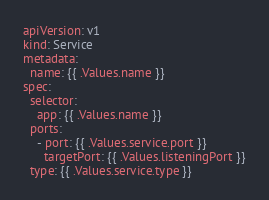Convert code to text. <code><loc_0><loc_0><loc_500><loc_500><_YAML_>apiVersion: v1
kind: Service
metadata:
  name: {{ .Values.name }}
spec:
  selector:
    app: {{ .Values.name }}
  ports:
    - port: {{ .Values.service.port }}
      targetPort: {{ .Values.listeningPort }}
  type: {{ .Values.service.type }}</code> 